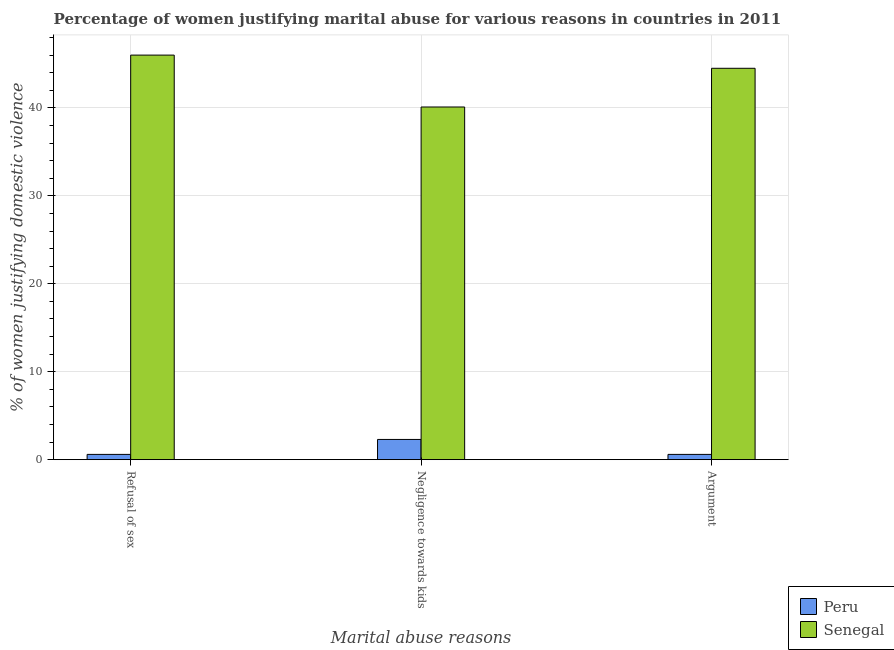How many groups of bars are there?
Provide a short and direct response. 3. How many bars are there on the 3rd tick from the left?
Make the answer very short. 2. What is the label of the 1st group of bars from the left?
Offer a terse response. Refusal of sex. What is the percentage of women justifying domestic violence due to negligence towards kids in Peru?
Provide a short and direct response. 2.3. Across all countries, what is the maximum percentage of women justifying domestic violence due to negligence towards kids?
Provide a short and direct response. 40.1. In which country was the percentage of women justifying domestic violence due to negligence towards kids maximum?
Give a very brief answer. Senegal. What is the total percentage of women justifying domestic violence due to refusal of sex in the graph?
Your answer should be compact. 46.6. What is the difference between the percentage of women justifying domestic violence due to negligence towards kids in Senegal and that in Peru?
Offer a terse response. 37.8. What is the difference between the percentage of women justifying domestic violence due to arguments in Senegal and the percentage of women justifying domestic violence due to negligence towards kids in Peru?
Your response must be concise. 42.2. What is the average percentage of women justifying domestic violence due to arguments per country?
Your answer should be very brief. 22.55. What is the difference between the percentage of women justifying domestic violence due to negligence towards kids and percentage of women justifying domestic violence due to arguments in Senegal?
Your answer should be very brief. -4.4. What is the ratio of the percentage of women justifying domestic violence due to arguments in Peru to that in Senegal?
Your response must be concise. 0.01. What is the difference between the highest and the second highest percentage of women justifying domestic violence due to negligence towards kids?
Offer a terse response. 37.8. What is the difference between the highest and the lowest percentage of women justifying domestic violence due to arguments?
Provide a succinct answer. 43.9. What does the 2nd bar from the left in Refusal of sex represents?
Your answer should be very brief. Senegal. What does the 1st bar from the right in Argument represents?
Provide a succinct answer. Senegal. Is it the case that in every country, the sum of the percentage of women justifying domestic violence due to refusal of sex and percentage of women justifying domestic violence due to negligence towards kids is greater than the percentage of women justifying domestic violence due to arguments?
Make the answer very short. Yes. Are all the bars in the graph horizontal?
Offer a very short reply. No. Are the values on the major ticks of Y-axis written in scientific E-notation?
Provide a short and direct response. No. Does the graph contain any zero values?
Offer a terse response. No. Where does the legend appear in the graph?
Provide a short and direct response. Bottom right. What is the title of the graph?
Offer a terse response. Percentage of women justifying marital abuse for various reasons in countries in 2011. Does "World" appear as one of the legend labels in the graph?
Provide a succinct answer. No. What is the label or title of the X-axis?
Offer a terse response. Marital abuse reasons. What is the label or title of the Y-axis?
Offer a terse response. % of women justifying domestic violence. What is the % of women justifying domestic violence in Peru in Refusal of sex?
Offer a terse response. 0.6. What is the % of women justifying domestic violence in Senegal in Refusal of sex?
Offer a very short reply. 46. What is the % of women justifying domestic violence of Peru in Negligence towards kids?
Provide a short and direct response. 2.3. What is the % of women justifying domestic violence of Senegal in Negligence towards kids?
Your answer should be very brief. 40.1. What is the % of women justifying domestic violence of Senegal in Argument?
Make the answer very short. 44.5. Across all Marital abuse reasons, what is the maximum % of women justifying domestic violence of Peru?
Give a very brief answer. 2.3. Across all Marital abuse reasons, what is the minimum % of women justifying domestic violence in Senegal?
Your response must be concise. 40.1. What is the total % of women justifying domestic violence in Peru in the graph?
Offer a terse response. 3.5. What is the total % of women justifying domestic violence of Senegal in the graph?
Keep it short and to the point. 130.6. What is the difference between the % of women justifying domestic violence of Peru in Refusal of sex and that in Negligence towards kids?
Keep it short and to the point. -1.7. What is the difference between the % of women justifying domestic violence of Peru in Refusal of sex and that in Argument?
Keep it short and to the point. 0. What is the difference between the % of women justifying domestic violence in Senegal in Refusal of sex and that in Argument?
Your answer should be compact. 1.5. What is the difference between the % of women justifying domestic violence of Peru in Negligence towards kids and that in Argument?
Make the answer very short. 1.7. What is the difference between the % of women justifying domestic violence in Senegal in Negligence towards kids and that in Argument?
Your answer should be compact. -4.4. What is the difference between the % of women justifying domestic violence in Peru in Refusal of sex and the % of women justifying domestic violence in Senegal in Negligence towards kids?
Offer a terse response. -39.5. What is the difference between the % of women justifying domestic violence of Peru in Refusal of sex and the % of women justifying domestic violence of Senegal in Argument?
Your answer should be compact. -43.9. What is the difference between the % of women justifying domestic violence of Peru in Negligence towards kids and the % of women justifying domestic violence of Senegal in Argument?
Your answer should be very brief. -42.2. What is the average % of women justifying domestic violence of Peru per Marital abuse reasons?
Make the answer very short. 1.17. What is the average % of women justifying domestic violence in Senegal per Marital abuse reasons?
Offer a terse response. 43.53. What is the difference between the % of women justifying domestic violence of Peru and % of women justifying domestic violence of Senegal in Refusal of sex?
Keep it short and to the point. -45.4. What is the difference between the % of women justifying domestic violence of Peru and % of women justifying domestic violence of Senegal in Negligence towards kids?
Give a very brief answer. -37.8. What is the difference between the % of women justifying domestic violence in Peru and % of women justifying domestic violence in Senegal in Argument?
Keep it short and to the point. -43.9. What is the ratio of the % of women justifying domestic violence of Peru in Refusal of sex to that in Negligence towards kids?
Keep it short and to the point. 0.26. What is the ratio of the % of women justifying domestic violence of Senegal in Refusal of sex to that in Negligence towards kids?
Keep it short and to the point. 1.15. What is the ratio of the % of women justifying domestic violence of Senegal in Refusal of sex to that in Argument?
Your response must be concise. 1.03. What is the ratio of the % of women justifying domestic violence in Peru in Negligence towards kids to that in Argument?
Your answer should be compact. 3.83. What is the ratio of the % of women justifying domestic violence of Senegal in Negligence towards kids to that in Argument?
Provide a succinct answer. 0.9. What is the difference between the highest and the second highest % of women justifying domestic violence in Senegal?
Offer a very short reply. 1.5. 